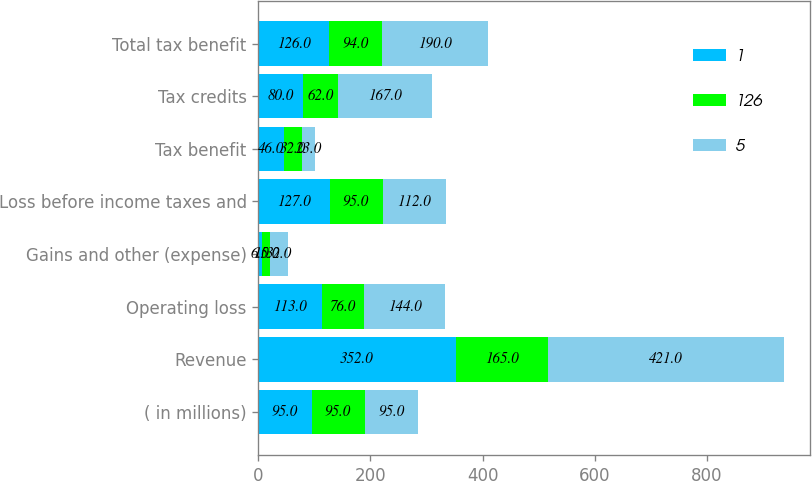Convert chart. <chart><loc_0><loc_0><loc_500><loc_500><stacked_bar_chart><ecel><fcel>( in millions)<fcel>Revenue<fcel>Operating loss<fcel>Gains and other (expense)<fcel>Loss before income taxes and<fcel>Tax benefit<fcel>Tax credits<fcel>Total tax benefit<nl><fcel>1<fcel>95<fcel>352<fcel>113<fcel>6<fcel>127<fcel>46<fcel>80<fcel>126<nl><fcel>126<fcel>95<fcel>165<fcel>76<fcel>15<fcel>95<fcel>32<fcel>62<fcel>94<nl><fcel>5<fcel>95<fcel>421<fcel>144<fcel>32<fcel>112<fcel>23<fcel>167<fcel>190<nl></chart> 